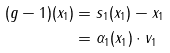<formula> <loc_0><loc_0><loc_500><loc_500>( g - 1 ) ( x _ { 1 } ) & = s _ { 1 } ( x _ { 1 } ) - x _ { 1 } \\ & = \alpha _ { 1 } ( x _ { 1 } ) \cdot v _ { 1 }</formula> 